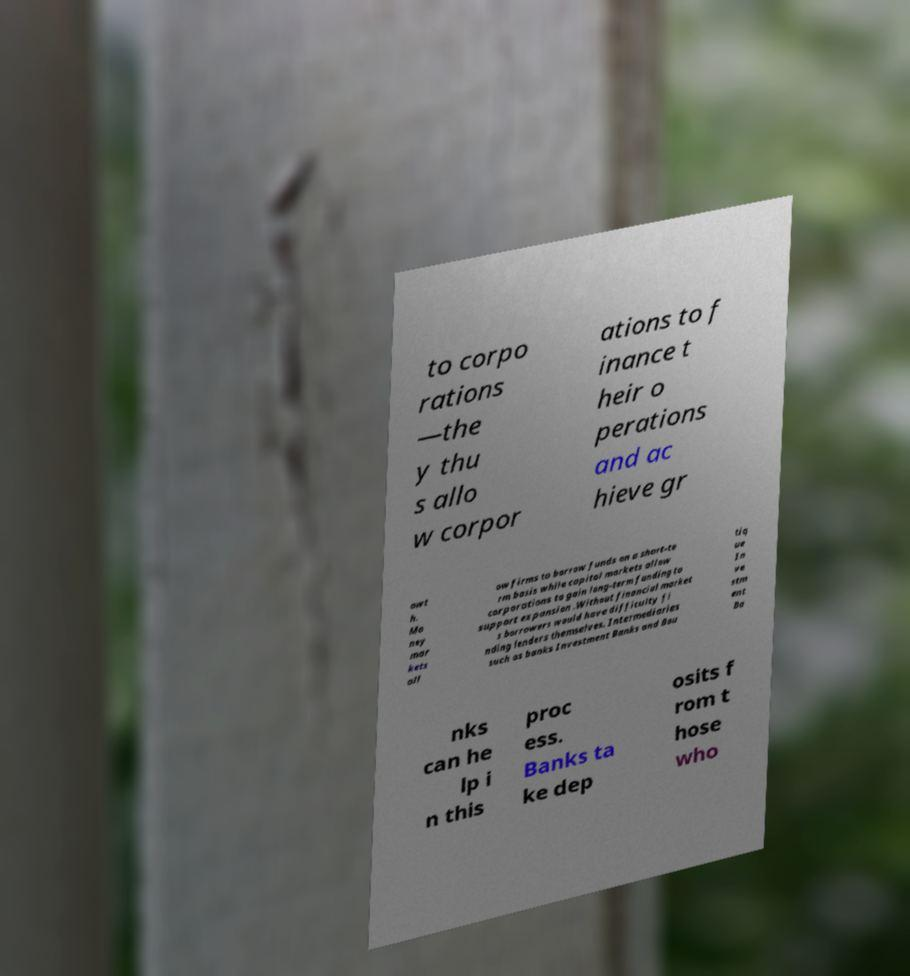Please read and relay the text visible in this image. What does it say? to corpo rations —the y thu s allo w corpor ations to f inance t heir o perations and ac hieve gr owt h. Mo ney mar kets all ow firms to borrow funds on a short-te rm basis while capital markets allow corporations to gain long-term funding to support expansion .Without financial market s borrowers would have difficulty fi nding lenders themselves. Intermediaries such as banks Investment Banks and Bou tiq ue In ve stm ent Ba nks can he lp i n this proc ess. Banks ta ke dep osits f rom t hose who 